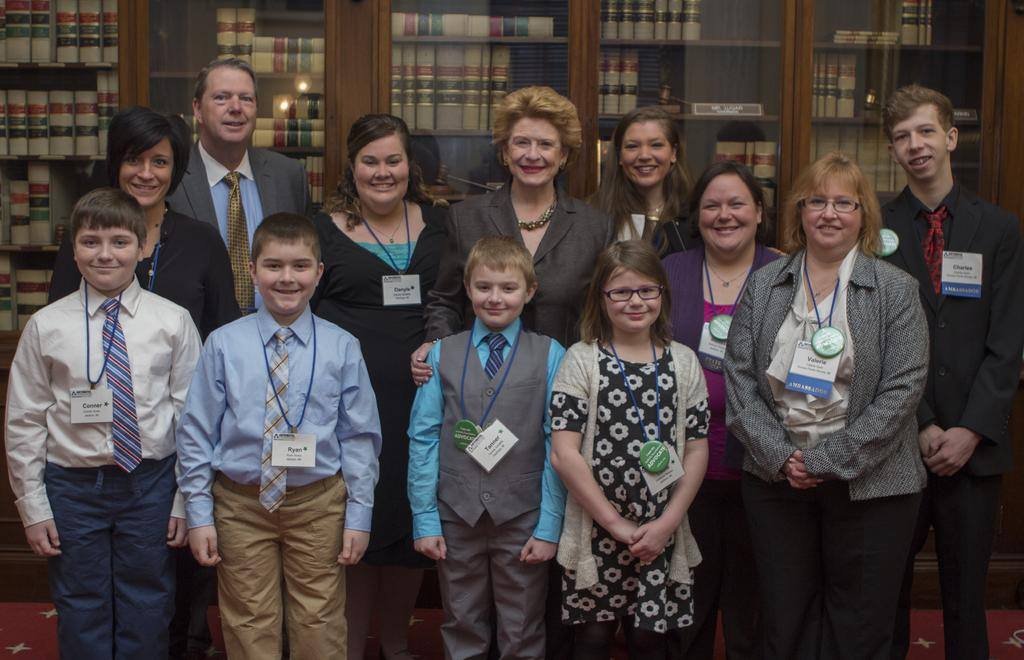What are the people in the image doing? The people in the image are standing and smiling. Can you describe any accessories the people are wearing? The people are wearing ID cards. What can be seen in the background of the image? There are books on shelves in the background of the image. What type of railway is visible in the image? There is no railway present in the image. What theory can be observed being put into practice in the image? The image does not depict any specific theory being put into practice. 